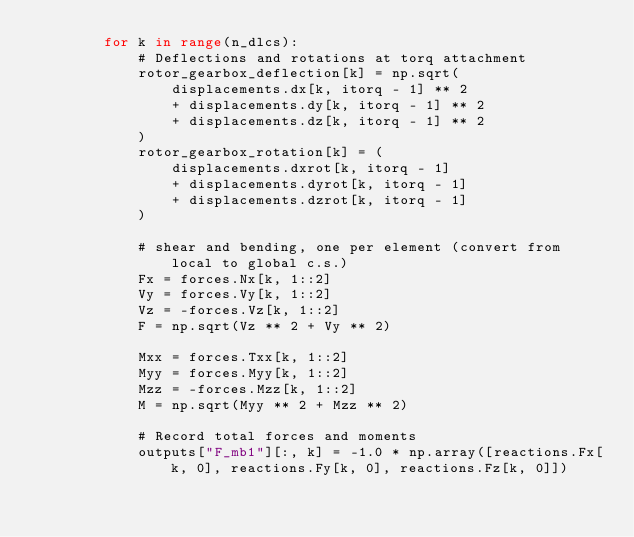Convert code to text. <code><loc_0><loc_0><loc_500><loc_500><_Python_>        for k in range(n_dlcs):
            # Deflections and rotations at torq attachment
            rotor_gearbox_deflection[k] = np.sqrt(
                displacements.dx[k, itorq - 1] ** 2
                + displacements.dy[k, itorq - 1] ** 2
                + displacements.dz[k, itorq - 1] ** 2
            )
            rotor_gearbox_rotation[k] = (
                displacements.dxrot[k, itorq - 1]
                + displacements.dyrot[k, itorq - 1]
                + displacements.dzrot[k, itorq - 1]
            )

            # shear and bending, one per element (convert from local to global c.s.)
            Fx = forces.Nx[k, 1::2]
            Vy = forces.Vy[k, 1::2]
            Vz = -forces.Vz[k, 1::2]
            F = np.sqrt(Vz ** 2 + Vy ** 2)

            Mxx = forces.Txx[k, 1::2]
            Myy = forces.Myy[k, 1::2]
            Mzz = -forces.Mzz[k, 1::2]
            M = np.sqrt(Myy ** 2 + Mzz ** 2)

            # Record total forces and moments
            outputs["F_mb1"][:, k] = -1.0 * np.array([reactions.Fx[k, 0], reactions.Fy[k, 0], reactions.Fz[k, 0]])</code> 